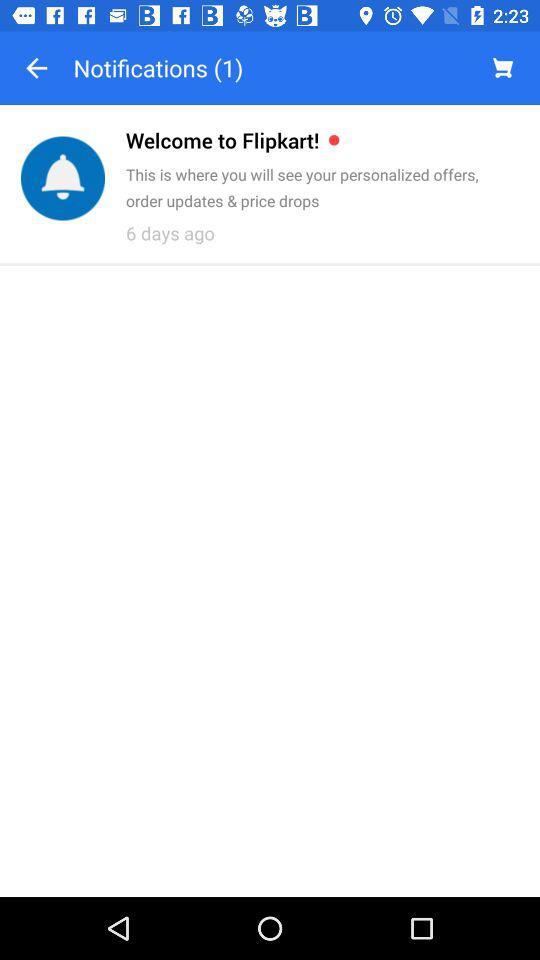How many notifications are pending? There is 1 pending notification. 